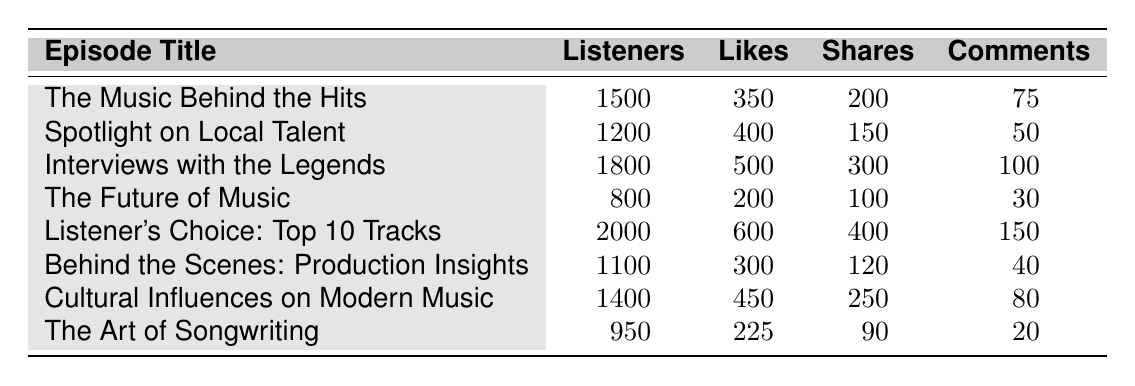What is the episode with the highest number of listeners? The episode with the highest number of listeners can be found by looking for the maximum value in the "Listeners" column of the table. Scanning through the values, "Listener's Choice: Top 10 Tracks" has the highest number of listeners at 2000.
Answer: Listener's Choice: Top 10 Tracks How many likes did "Interviews with the Legends" receive? To find the number of likes for the specific episode, refer to the "Likes" column for "Interviews with the Legends." The table shows it received 500 likes.
Answer: 500 What is the total number of shares for all episodes combined? To calculate the total shares, we need to sum the "Shares" values from all episodes: 200 + 150 + 300 + 100 + 400 + 120 + 250 + 90 = 1610. Thus, the total number of shares is 1610.
Answer: 1610 Did "The Future of Music" receive more likes than "The Art of Songwriting"? Comparing the likes for both episodes, "The Future of Music" has 200 likes, while "The Art of Songwriting" has 225 likes. Therefore, "The Future of Music" did not receive more likes.
Answer: No What is the average number of comments for the episodes? To find the average number of comments, we sum the "Comments" values: 75 + 50 + 100 + 30 + 150 + 40 + 80 + 20 = 545. The number of episodes is 8, so the average is calculated as 545/8, which is 68.125. Hence, the average number of comments is approximately 68.
Answer: 68.125 How many episodes had more than 300 listeners? By examining the "Listeners" column, we can identify episodes with more than 300 listeners. The episodes with listener counts of 1500, 1200, 1800, 2000, 1100, 1400, and 950 all exceed 300 listeners. Counting these gives us a total of 7 episodes.
Answer: 7 Which episode had the least number of comments? To find the episode with the least number of comments, we look through the "Comments" column. "The Art of Songwriting" has the lowest number of comments at 20.
Answer: The Art of Songwriting Is it true that "Cultural Influences on Modern Music" had more likes than "Behind the Scenes: Production Insights"? By comparing the likes, "Cultural Influences on Modern Music" had 450 likes, while "Behind the Scenes: Production Insights" had 300 likes. Thus, it is true that the former had more likes.
Answer: Yes 